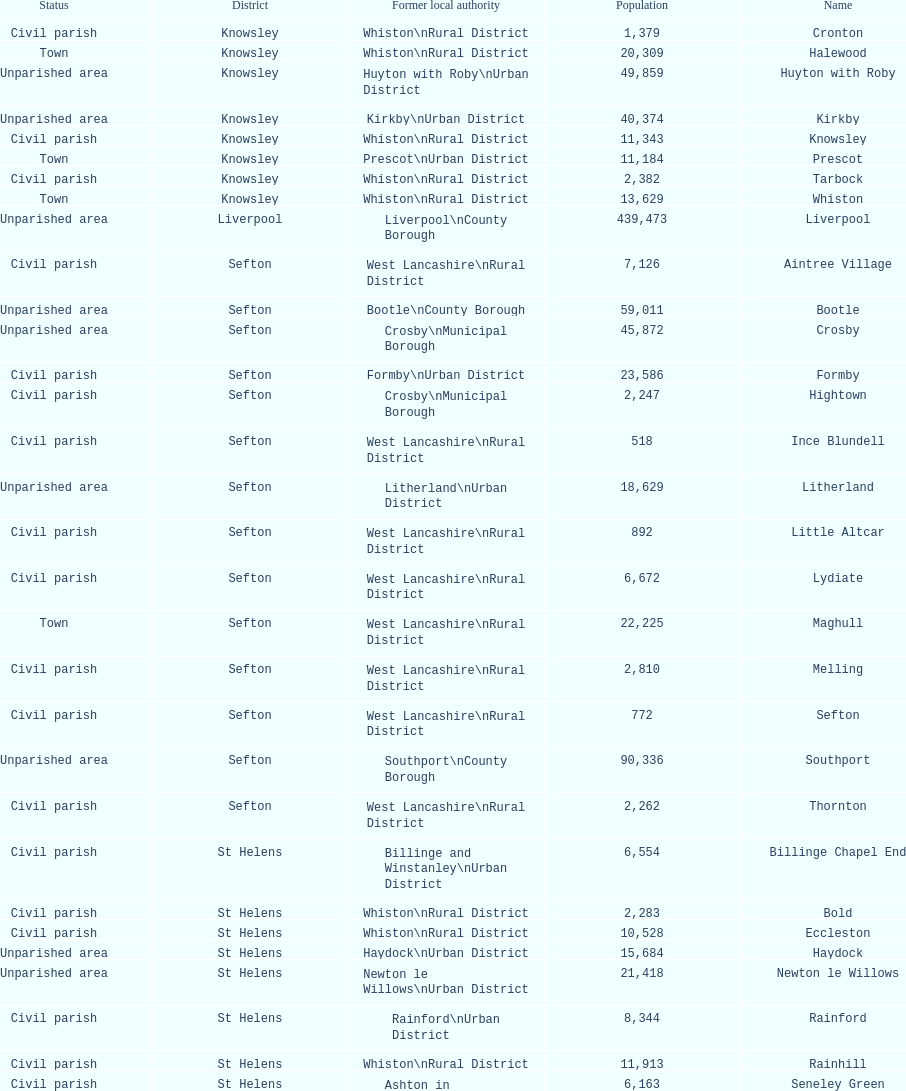How many areas are unparished areas? 15. 